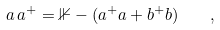Convert formula to latex. <formula><loc_0><loc_0><loc_500><loc_500>a \, a ^ { + } = { \mathbb { 1 } } - ( a ^ { + } a + b ^ { + } b ) \quad ,</formula> 